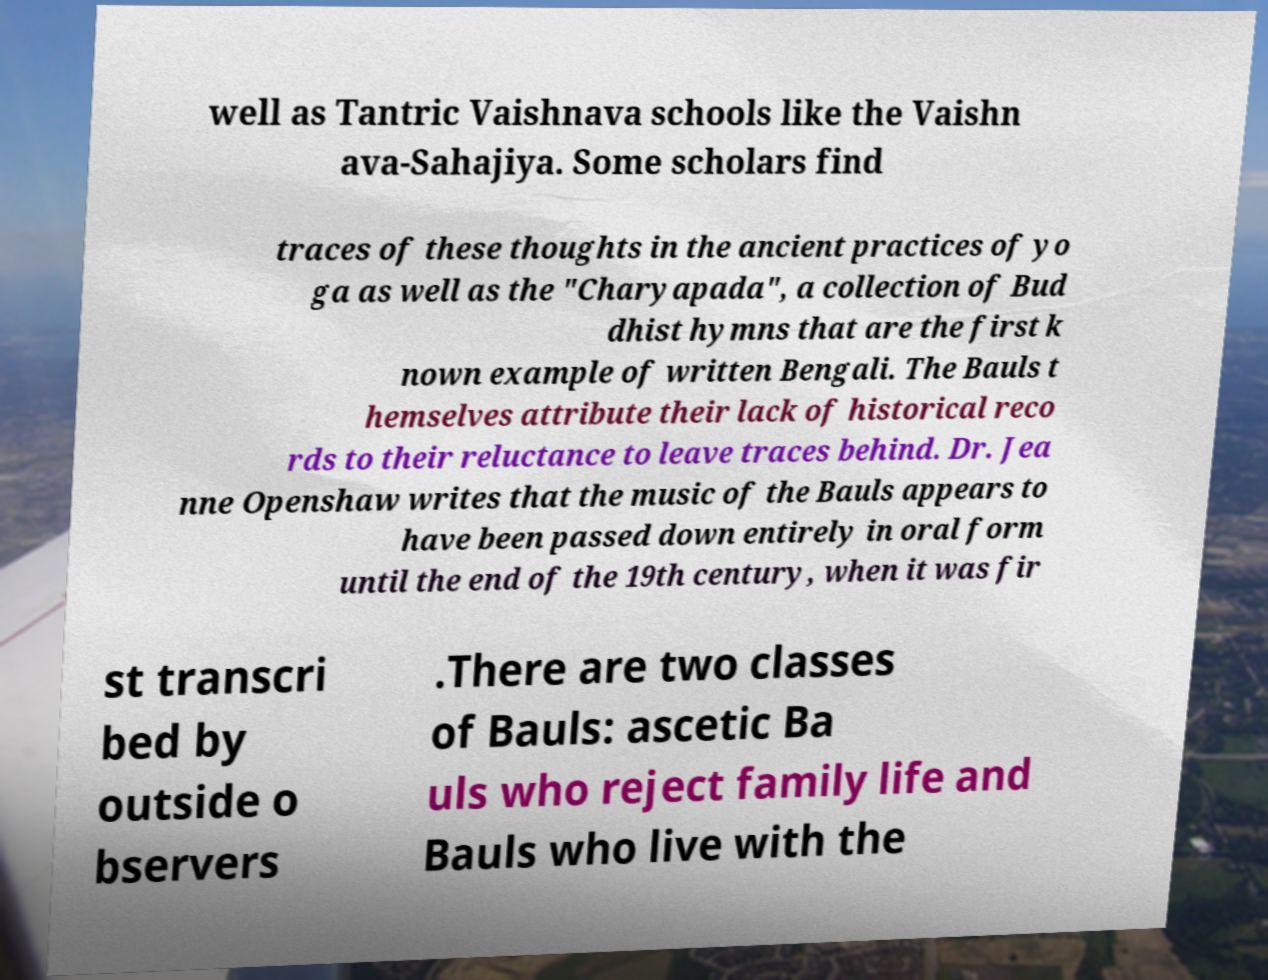Please identify and transcribe the text found in this image. well as Tantric Vaishnava schools like the Vaishn ava-Sahajiya. Some scholars find traces of these thoughts in the ancient practices of yo ga as well as the "Charyapada", a collection of Bud dhist hymns that are the first k nown example of written Bengali. The Bauls t hemselves attribute their lack of historical reco rds to their reluctance to leave traces behind. Dr. Jea nne Openshaw writes that the music of the Bauls appears to have been passed down entirely in oral form until the end of the 19th century, when it was fir st transcri bed by outside o bservers .There are two classes of Bauls: ascetic Ba uls who reject family life and Bauls who live with the 